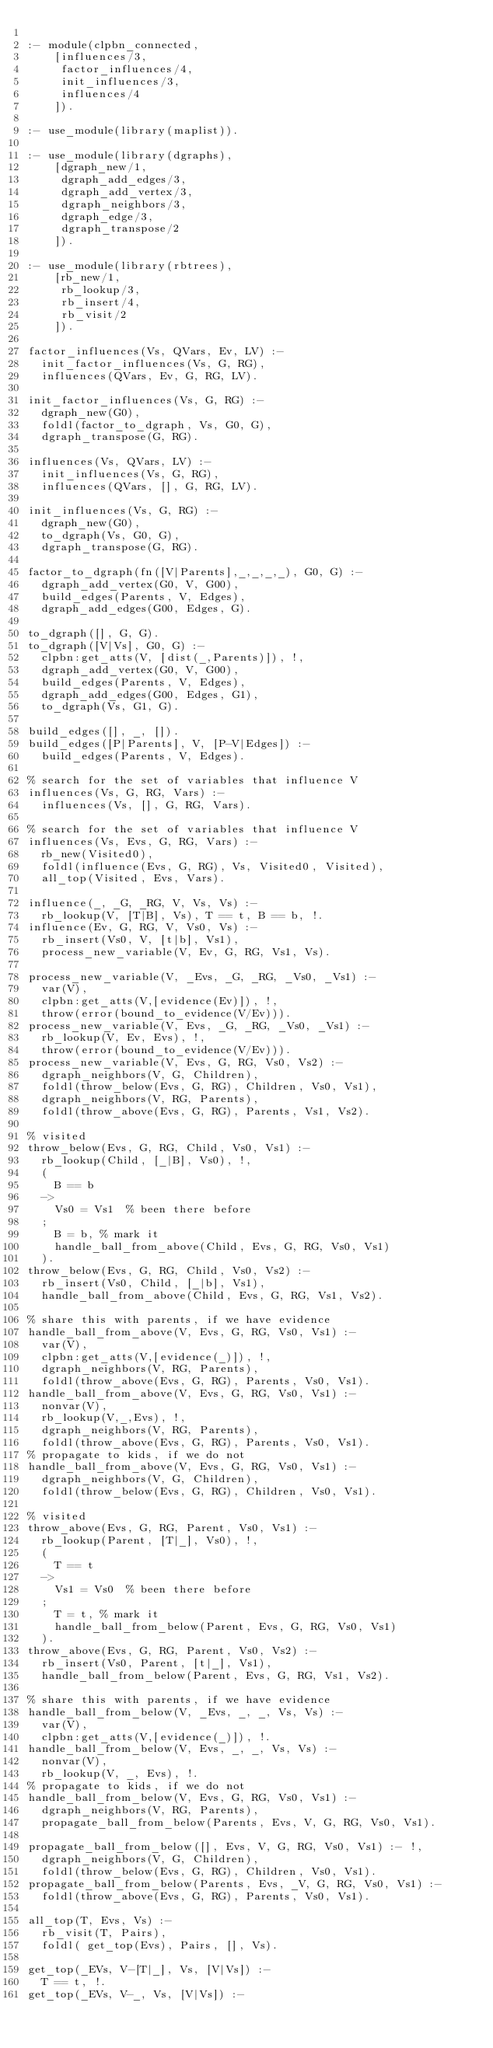<code> <loc_0><loc_0><loc_500><loc_500><_Prolog_>
:- module(clpbn_connected,
		[influences/3,
		 factor_influences/4,
		 init_influences/3,
		 influences/4
		]).

:- use_module(library(maplist)).

:- use_module(library(dgraphs),
		[dgraph_new/1,
		 dgraph_add_edges/3,
		 dgraph_add_vertex/3,
		 dgraph_neighbors/3,
		 dgraph_edge/3,
		 dgraph_transpose/2
		]).

:- use_module(library(rbtrees),
		[rb_new/1,
		 rb_lookup/3,
		 rb_insert/4,
		 rb_visit/2
		]).

factor_influences(Vs, QVars, Ev, LV) :-
	init_factor_influences(Vs, G, RG),
	influences(QVars, Ev, G, RG, LV).

init_factor_influences(Vs, G, RG) :-
	dgraph_new(G0),
	foldl(factor_to_dgraph, Vs, G0, G),
	dgraph_transpose(G, RG).

influences(Vs, QVars, LV) :-
	init_influences(Vs, G, RG),
	influences(QVars, [], G, RG, LV).

init_influences(Vs, G, RG) :-
	dgraph_new(G0),
	to_dgraph(Vs, G0, G),
	dgraph_transpose(G, RG).

factor_to_dgraph(fn([V|Parents],_,_,_,_), G0, G) :-
	dgraph_add_vertex(G0, V, G00),
	build_edges(Parents, V, Edges),
	dgraph_add_edges(G00, Edges, G).

to_dgraph([], G, G).
to_dgraph([V|Vs], G0, G) :-
	clpbn:get_atts(V, [dist(_,Parents)]), !,
	dgraph_add_vertex(G0, V, G00),
	build_edges(Parents, V, Edges),
	dgraph_add_edges(G00, Edges, G1),
	to_dgraph(Vs, G1, G).

build_edges([], _, []).
build_edges([P|Parents], V, [P-V|Edges]) :-
	build_edges(Parents, V, Edges).

% search for the set of variables that influence V
influences(Vs, G, RG, Vars) :-
	influences(Vs, [], G, RG, Vars).

% search for the set of variables that influence V
influences(Vs, Evs, G, RG, Vars) :-
	rb_new(Visited0),
	foldl(influence(Evs, G, RG), Vs, Visited0, Visited),
	all_top(Visited, Evs, Vars).

influence(_, _G, _RG, V, Vs, Vs) :-
	rb_lookup(V, [T|B], Vs), T == t, B == b, !.
influence(Ev, G, RG, V, Vs0, Vs) :-
	rb_insert(Vs0, V, [t|b], Vs1),
	process_new_variable(V, Ev, G, RG, Vs1, Vs).

process_new_variable(V, _Evs, _G, _RG, _Vs0, _Vs1) :-
	var(V),
	clpbn:get_atts(V,[evidence(Ev)]), !,
	throw(error(bound_to_evidence(V/Ev))).
process_new_variable(V, Evs, _G, _RG, _Vs0, _Vs1) :-
	rb_lookup(V, Ev, Evs), !,
	throw(error(bound_to_evidence(V/Ev))).
process_new_variable(V, Evs, G, RG, Vs0, Vs2) :-
	dgraph_neighbors(V, G, Children),
	foldl(throw_below(Evs, G, RG), Children, Vs0, Vs1),
	dgraph_neighbors(V, RG, Parents),
	foldl(throw_above(Evs, G, RG), Parents, Vs1, Vs2).

% visited
throw_below(Evs, G, RG, Child, Vs0, Vs1) :-
	rb_lookup(Child, [_|B], Vs0), !,
	(
	  B == b
	->
	  Vs0 = Vs1  % been there before
	;
	  B = b, % mark it
	  handle_ball_from_above(Child, Evs, G, RG, Vs0, Vs1)
	).
throw_below(Evs, G, RG, Child, Vs0, Vs2) :-
	rb_insert(Vs0, Child, [_|b], Vs1),
	handle_ball_from_above(Child, Evs, G, RG, Vs1, Vs2).

% share this with parents, if we have evidence
handle_ball_from_above(V, Evs, G, RG, Vs0, Vs1) :-
	var(V),
	clpbn:get_atts(V,[evidence(_)]), !,
	dgraph_neighbors(V, RG, Parents),
	foldl(throw_above(Evs, G, RG), Parents, Vs0, Vs1).
handle_ball_from_above(V, Evs, G, RG, Vs0, Vs1) :-
	nonvar(V),
	rb_lookup(V,_,Evs), !,
	dgraph_neighbors(V, RG, Parents),
	foldl(throw_above(Evs, G, RG), Parents, Vs0, Vs1).
% propagate to kids, if we do not
handle_ball_from_above(V, Evs, G, RG, Vs0, Vs1) :-
	dgraph_neighbors(V, G, Children),
	foldl(throw_below(Evs, G, RG), Children, Vs0, Vs1).

% visited
throw_above(Evs, G, RG, Parent, Vs0, Vs1) :-
	rb_lookup(Parent, [T|_], Vs0), !,
	(
	  T == t
	->
	  Vs1 = Vs0  % been there before
	;
	  T = t, % mark it
	  handle_ball_from_below(Parent, Evs, G, RG, Vs0, Vs1)
	).
throw_above(Evs, G, RG, Parent, Vs0, Vs2) :-
	rb_insert(Vs0, Parent, [t|_], Vs1),
	handle_ball_from_below(Parent, Evs, G, RG, Vs1, Vs2).

% share this with parents, if we have evidence
handle_ball_from_below(V, _Evs, _, _, Vs, Vs) :-
	var(V),
	clpbn:get_atts(V,[evidence(_)]), !.
handle_ball_from_below(V, Evs, _, _, Vs, Vs) :-
	nonvar(V),
	rb_lookup(V, _, Evs), !.
% propagate to kids, if we do not
handle_ball_from_below(V, Evs, G, RG, Vs0, Vs1) :-
	dgraph_neighbors(V, RG, Parents),
	propagate_ball_from_below(Parents, Evs, V, G, RG, Vs0, Vs1).

propagate_ball_from_below([], Evs, V, G, RG, Vs0, Vs1) :- !,
	dgraph_neighbors(V, G, Children),
	foldl(throw_below(Evs, G, RG), Children, Vs0, Vs1).
propagate_ball_from_below(Parents, Evs, _V, G, RG, Vs0, Vs1) :-
	foldl(throw_above(Evs, G, RG), Parents, Vs0, Vs1).

all_top(T, Evs, Vs) :-
	rb_visit(T, Pairs),
	foldl( get_top(Evs), Pairs, [], Vs).

get_top(_EVs, V-[T|_], Vs, [V|Vs]) :-
	T == t, !.
get_top(_EVs, V-_, Vs, [V|Vs]) :-</code> 